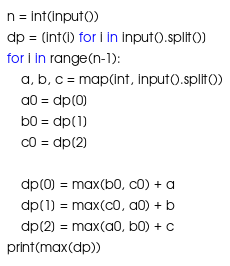<code> <loc_0><loc_0><loc_500><loc_500><_Python_>n = int(input())
dp = [int(i) for i in input().split()]
for i in range(n-1):
    a, b, c = map(int, input().split())
    a0 = dp[0]
    b0 = dp[1]
    c0 = dp[2]
    
    dp[0] = max(b0, c0) + a
    dp[1] = max(c0, a0) + b
    dp[2] = max(a0, b0) + c
print(max(dp))</code> 